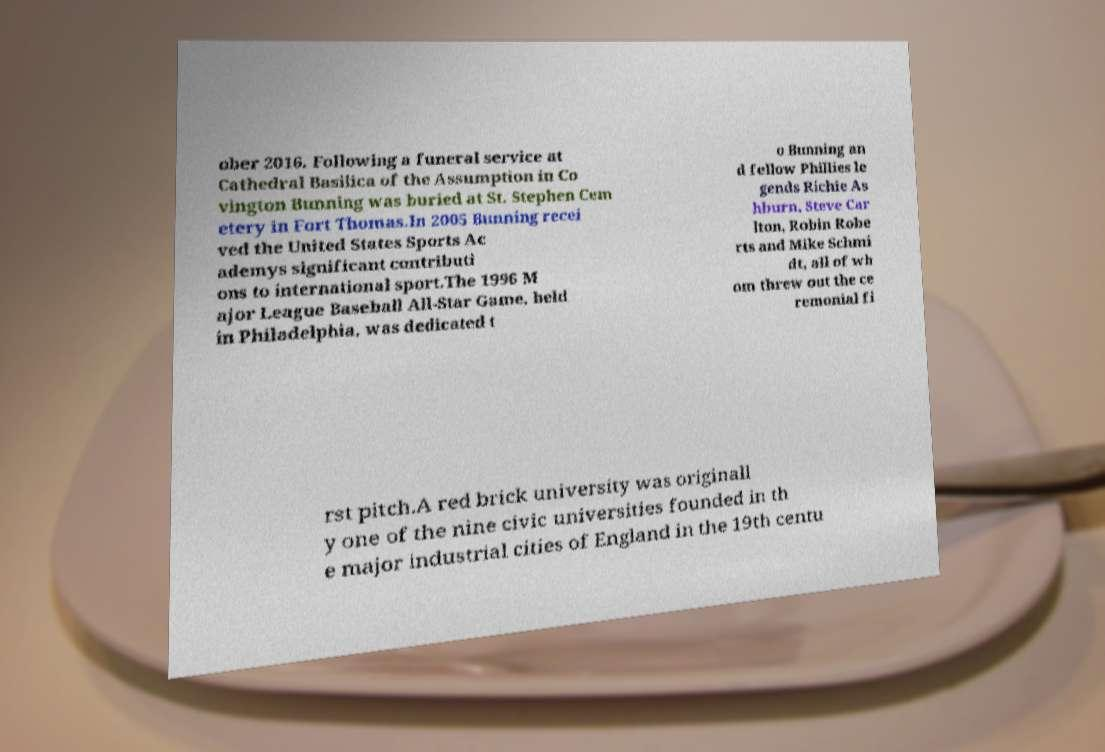Please identify and transcribe the text found in this image. ober 2016. Following a funeral service at Cathedral Basilica of the Assumption in Co vington Bunning was buried at St. Stephen Cem etery in Fort Thomas.In 2005 Bunning recei ved the United States Sports Ac ademys significant contributi ons to international sport.The 1996 M ajor League Baseball All-Star Game, held in Philadelphia, was dedicated t o Bunning an d fellow Phillies le gends Richie As hburn, Steve Car lton, Robin Robe rts and Mike Schmi dt, all of wh om threw out the ce remonial fi rst pitch.A red brick university was originall y one of the nine civic universities founded in th e major industrial cities of England in the 19th centu 